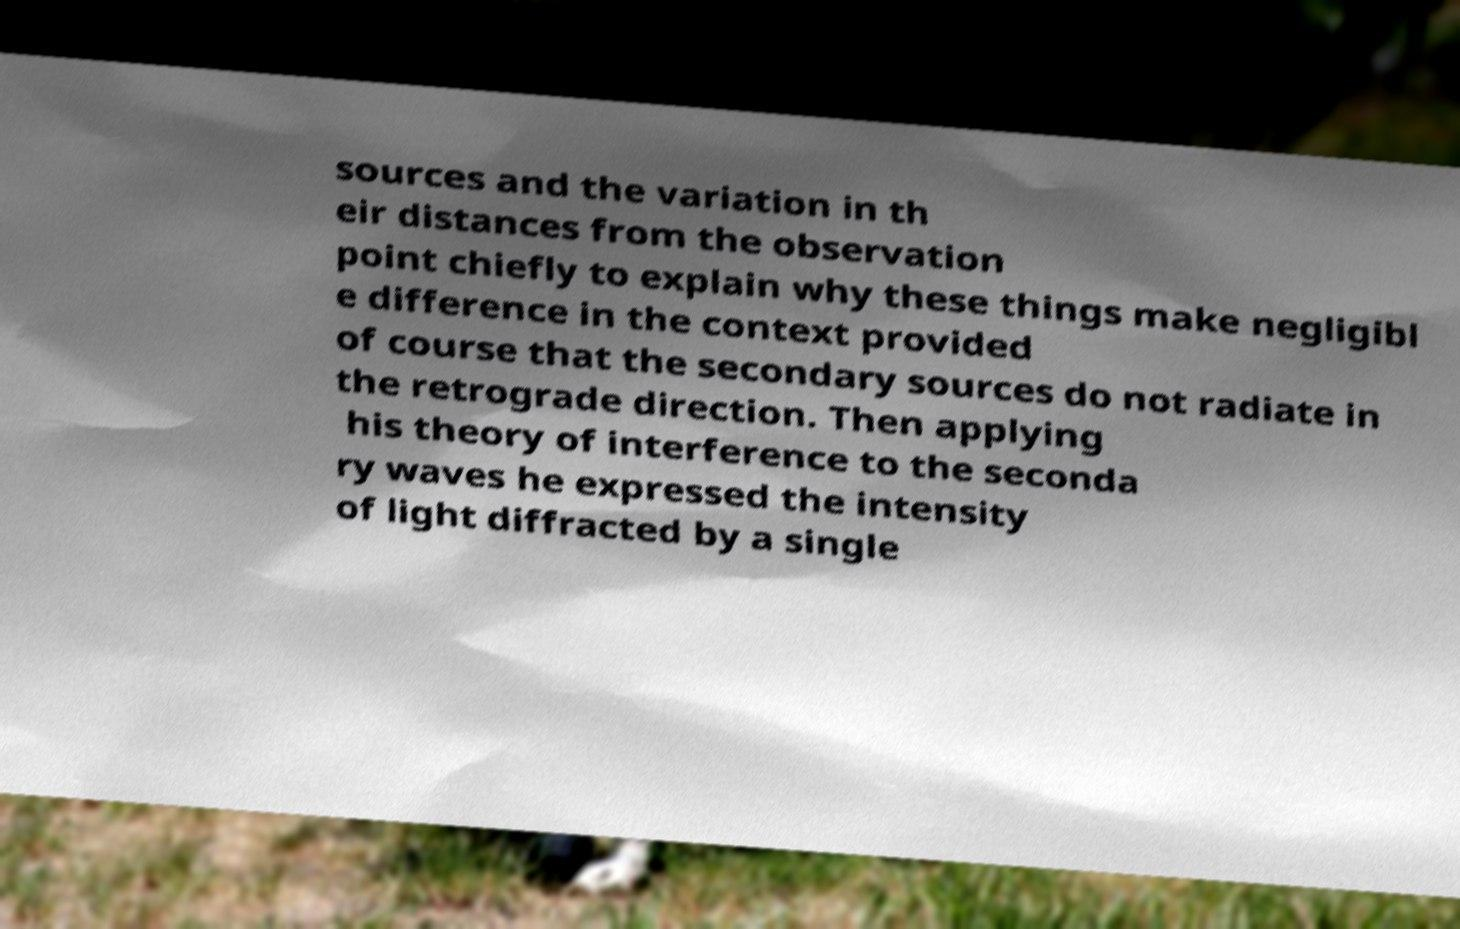What messages or text are displayed in this image? I need them in a readable, typed format. sources and the variation in th eir distances from the observation point chiefly to explain why these things make negligibl e difference in the context provided of course that the secondary sources do not radiate in the retrograde direction. Then applying his theory of interference to the seconda ry waves he expressed the intensity of light diffracted by a single 